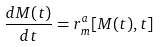<formula> <loc_0><loc_0><loc_500><loc_500>\frac { d M ( t ) } { d t } = r ^ { a } _ { m } [ M ( t ) , t ]</formula> 